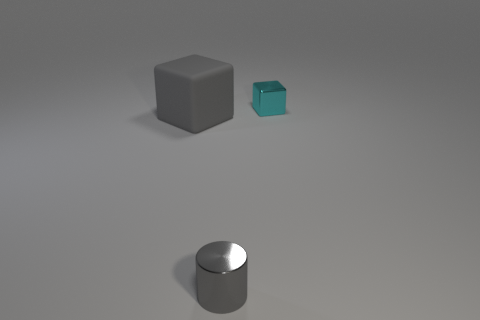Are there any other things that have the same material as the big gray block?
Your answer should be compact. No. Does the rubber cube have the same color as the small metal cylinder?
Offer a very short reply. Yes. What color is the small cylinder that is the same material as the cyan thing?
Give a very brief answer. Gray. Do the block to the right of the cylinder and the small object that is to the left of the cyan shiny block have the same material?
Make the answer very short. Yes. What is the size of the other object that is the same color as the big object?
Offer a very short reply. Small. There is a tiny gray object in front of the cyan metal cube; what is it made of?
Provide a short and direct response. Metal. Is the shape of the thing behind the gray block the same as the gray thing that is to the left of the gray metallic cylinder?
Your response must be concise. Yes. What material is the cylinder that is the same color as the big matte object?
Your answer should be very brief. Metal. Are there any shiny cubes?
Ensure brevity in your answer.  Yes. There is a large thing that is the same shape as the small cyan metallic object; what is it made of?
Your response must be concise. Rubber. 